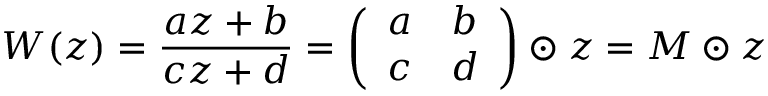<formula> <loc_0><loc_0><loc_500><loc_500>W ( z ) = \frac { a z + b } { c z + d } = \left ( \begin{array} { c c } { a } & { b } \\ { c } & { d } \end{array} \right ) \odot z = M \odot z</formula> 